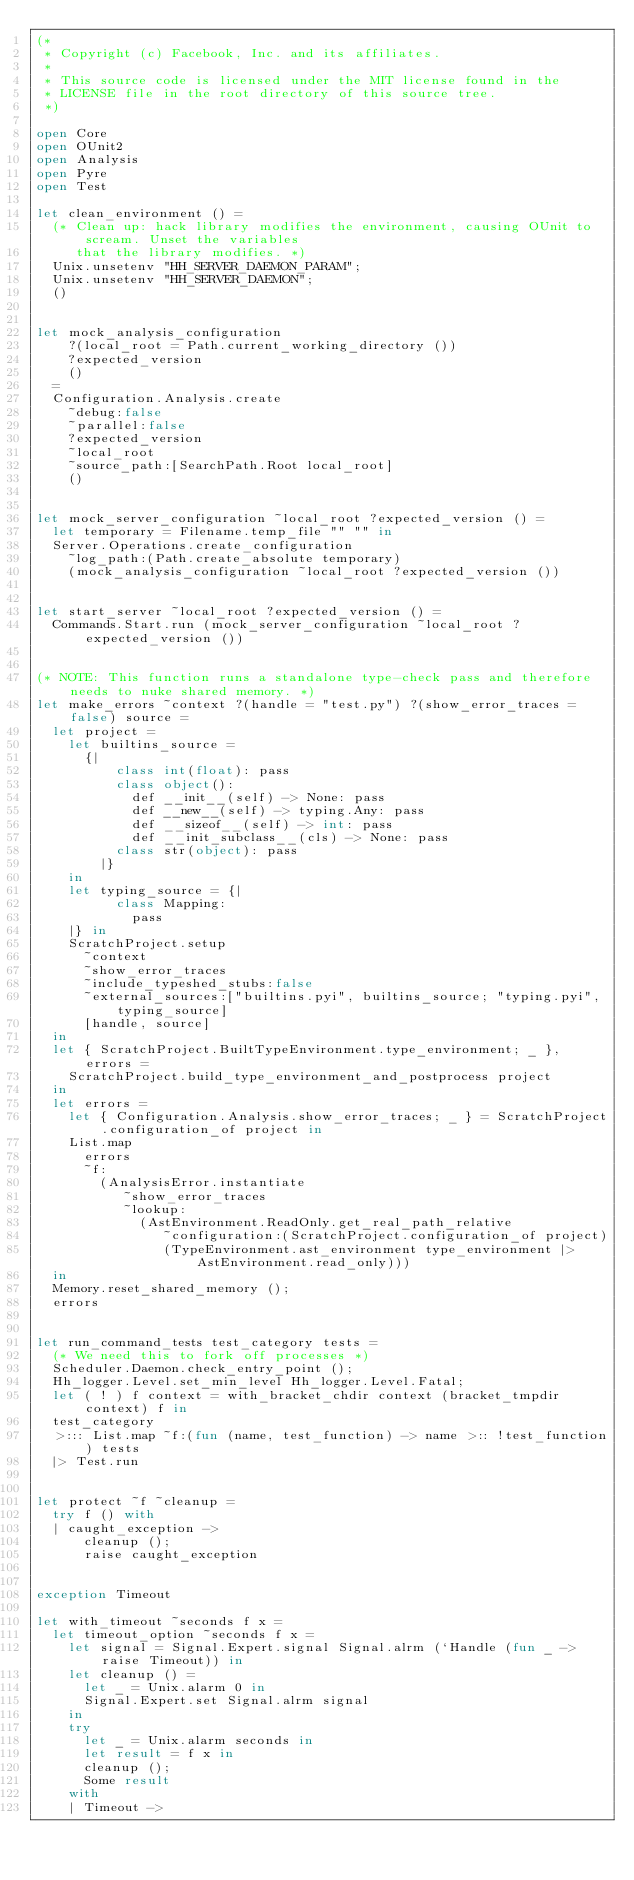<code> <loc_0><loc_0><loc_500><loc_500><_OCaml_>(*
 * Copyright (c) Facebook, Inc. and its affiliates.
 *
 * This source code is licensed under the MIT license found in the
 * LICENSE file in the root directory of this source tree.
 *)

open Core
open OUnit2
open Analysis
open Pyre
open Test

let clean_environment () =
  (* Clean up: hack library modifies the environment, causing OUnit to scream. Unset the variables
     that the library modifies. *)
  Unix.unsetenv "HH_SERVER_DAEMON_PARAM";
  Unix.unsetenv "HH_SERVER_DAEMON";
  ()


let mock_analysis_configuration
    ?(local_root = Path.current_working_directory ())
    ?expected_version
    ()
  =
  Configuration.Analysis.create
    ~debug:false
    ~parallel:false
    ?expected_version
    ~local_root
    ~source_path:[SearchPath.Root local_root]
    ()


let mock_server_configuration ~local_root ?expected_version () =
  let temporary = Filename.temp_file "" "" in
  Server.Operations.create_configuration
    ~log_path:(Path.create_absolute temporary)
    (mock_analysis_configuration ~local_root ?expected_version ())


let start_server ~local_root ?expected_version () =
  Commands.Start.run (mock_server_configuration ~local_root ?expected_version ())


(* NOTE: This function runs a standalone type-check pass and therefore needs to nuke shared memory. *)
let make_errors ~context ?(handle = "test.py") ?(show_error_traces = false) source =
  let project =
    let builtins_source =
      {|
          class int(float): pass
          class object():
            def __init__(self) -> None: pass
            def __new__(self) -> typing.Any: pass
            def __sizeof__(self) -> int: pass
            def __init_subclass__(cls) -> None: pass
          class str(object): pass
        |}
    in
    let typing_source = {|
          class Mapping:
            pass
    |} in
    ScratchProject.setup
      ~context
      ~show_error_traces
      ~include_typeshed_stubs:false
      ~external_sources:["builtins.pyi", builtins_source; "typing.pyi", typing_source]
      [handle, source]
  in
  let { ScratchProject.BuiltTypeEnvironment.type_environment; _ }, errors =
    ScratchProject.build_type_environment_and_postprocess project
  in
  let errors =
    let { Configuration.Analysis.show_error_traces; _ } = ScratchProject.configuration_of project in
    List.map
      errors
      ~f:
        (AnalysisError.instantiate
           ~show_error_traces
           ~lookup:
             (AstEnvironment.ReadOnly.get_real_path_relative
                ~configuration:(ScratchProject.configuration_of project)
                (TypeEnvironment.ast_environment type_environment |> AstEnvironment.read_only)))
  in
  Memory.reset_shared_memory ();
  errors


let run_command_tests test_category tests =
  (* We need this to fork off processes *)
  Scheduler.Daemon.check_entry_point ();
  Hh_logger.Level.set_min_level Hh_logger.Level.Fatal;
  let ( ! ) f context = with_bracket_chdir context (bracket_tmpdir context) f in
  test_category
  >::: List.map ~f:(fun (name, test_function) -> name >:: !test_function) tests
  |> Test.run


let protect ~f ~cleanup =
  try f () with
  | caught_exception ->
      cleanup ();
      raise caught_exception


exception Timeout

let with_timeout ~seconds f x =
  let timeout_option ~seconds f x =
    let signal = Signal.Expert.signal Signal.alrm (`Handle (fun _ -> raise Timeout)) in
    let cleanup () =
      let _ = Unix.alarm 0 in
      Signal.Expert.set Signal.alrm signal
    in
    try
      let _ = Unix.alarm seconds in
      let result = f x in
      cleanup ();
      Some result
    with
    | Timeout -></code> 